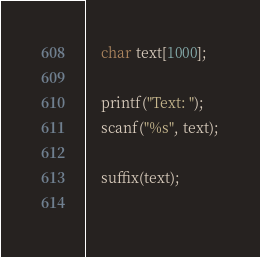Convert code to text. <code><loc_0><loc_0><loc_500><loc_500><_C_>    char text[1000];
    
    printf("Text: ");
    scanf("%s", text);
    
    suffix(text);
    </code> 